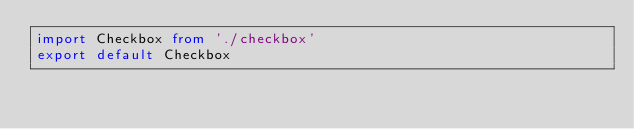<code> <loc_0><loc_0><loc_500><loc_500><_TypeScript_>import Checkbox from './checkbox'
export default Checkbox </code> 